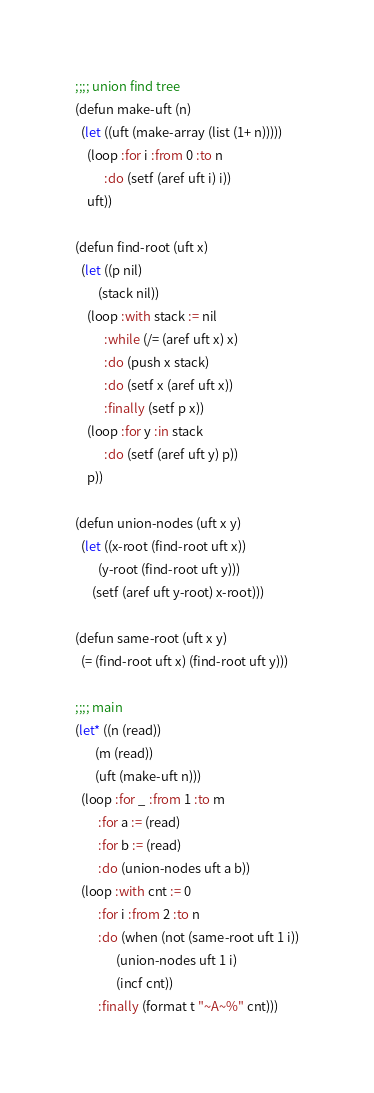Convert code to text. <code><loc_0><loc_0><loc_500><loc_500><_Lisp_>;;;; union find tree
(defun make-uft (n)
  (let ((uft (make-array (list (1+ n)))))
    (loop :for i :from 0 :to n
          :do (setf (aref uft i) i))
    uft))

(defun find-root (uft x)
  (let ((p nil)
        (stack nil))
    (loop :with stack := nil
          :while (/= (aref uft x) x)
          :do (push x stack)
          :do (setf x (aref uft x))
          :finally (setf p x))
    (loop :for y :in stack
          :do (setf (aref uft y) p))
    p))

(defun union-nodes (uft x y)
  (let ((x-root (find-root uft x))
        (y-root (find-root uft y)))
      (setf (aref uft y-root) x-root)))

(defun same-root (uft x y)
  (= (find-root uft x) (find-root uft y)))

;;;; main
(let* ((n (read))
       (m (read))
       (uft (make-uft n)))
  (loop :for _ :from 1 :to m
        :for a := (read)
        :for b := (read)
        :do (union-nodes uft a b))
  (loop :with cnt := 0
        :for i :from 2 :to n
        :do (when (not (same-root uft 1 i))
              (union-nodes uft 1 i)
              (incf cnt))
        :finally (format t "~A~%" cnt)))
</code> 